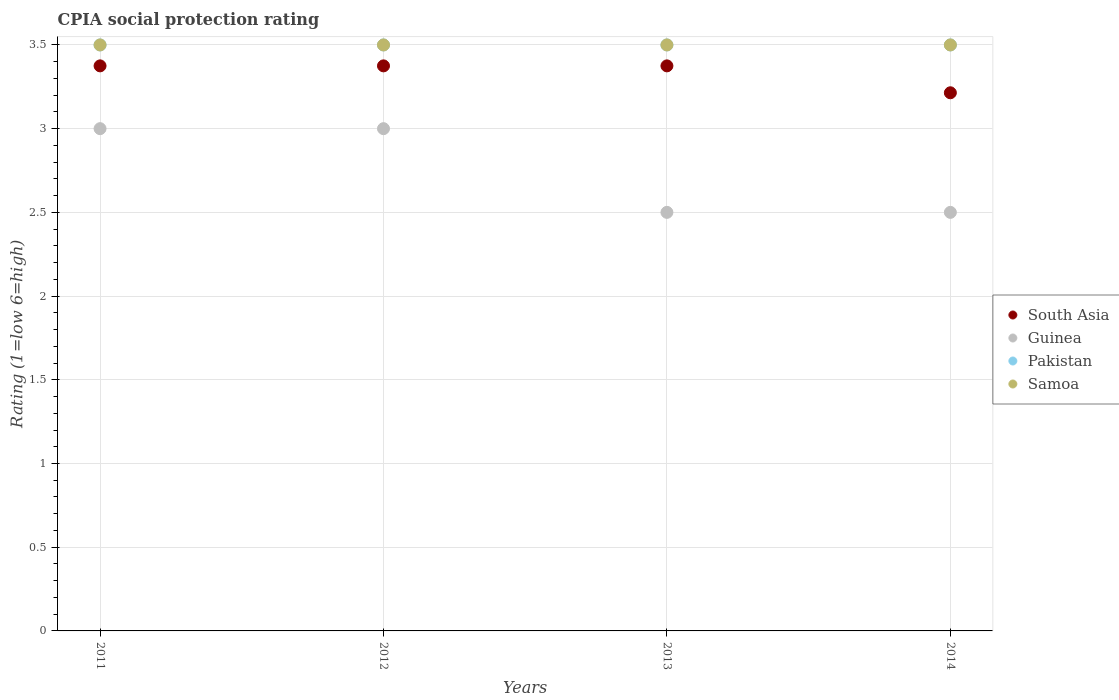Is the number of dotlines equal to the number of legend labels?
Keep it short and to the point. Yes. What is the CPIA rating in South Asia in 2011?
Keep it short and to the point. 3.38. Across all years, what is the maximum CPIA rating in South Asia?
Offer a terse response. 3.38. In which year was the CPIA rating in Pakistan maximum?
Your answer should be very brief. 2011. In which year was the CPIA rating in Pakistan minimum?
Provide a short and direct response. 2011. What is the difference between the CPIA rating in Pakistan in 2013 and that in 2014?
Give a very brief answer. 0. What is the difference between the CPIA rating in Samoa in 2014 and the CPIA rating in South Asia in 2012?
Offer a very short reply. 0.12. What is the average CPIA rating in South Asia per year?
Ensure brevity in your answer.  3.33. In how many years, is the CPIA rating in Guinea greater than 1?
Offer a terse response. 4. What is the ratio of the CPIA rating in Guinea in 2011 to that in 2012?
Ensure brevity in your answer.  1. Is it the case that in every year, the sum of the CPIA rating in Samoa and CPIA rating in Pakistan  is greater than the CPIA rating in Guinea?
Offer a very short reply. Yes. Does the CPIA rating in Pakistan monotonically increase over the years?
Make the answer very short. No. How many dotlines are there?
Provide a short and direct response. 4. How many years are there in the graph?
Offer a terse response. 4. Are the values on the major ticks of Y-axis written in scientific E-notation?
Provide a succinct answer. No. Does the graph contain any zero values?
Make the answer very short. No. Where does the legend appear in the graph?
Your response must be concise. Center right. What is the title of the graph?
Offer a terse response. CPIA social protection rating. What is the label or title of the X-axis?
Keep it short and to the point. Years. What is the label or title of the Y-axis?
Your answer should be very brief. Rating (1=low 6=high). What is the Rating (1=low 6=high) of South Asia in 2011?
Offer a very short reply. 3.38. What is the Rating (1=low 6=high) of Samoa in 2011?
Your answer should be very brief. 3.5. What is the Rating (1=low 6=high) in South Asia in 2012?
Your response must be concise. 3.38. What is the Rating (1=low 6=high) of Guinea in 2012?
Give a very brief answer. 3. What is the Rating (1=low 6=high) of Pakistan in 2012?
Your answer should be compact. 3.5. What is the Rating (1=low 6=high) in Samoa in 2012?
Offer a terse response. 3.5. What is the Rating (1=low 6=high) of South Asia in 2013?
Offer a very short reply. 3.38. What is the Rating (1=low 6=high) in Guinea in 2013?
Ensure brevity in your answer.  2.5. What is the Rating (1=low 6=high) in Pakistan in 2013?
Offer a terse response. 3.5. What is the Rating (1=low 6=high) of Samoa in 2013?
Offer a terse response. 3.5. What is the Rating (1=low 6=high) of South Asia in 2014?
Your answer should be very brief. 3.21. What is the Rating (1=low 6=high) in Pakistan in 2014?
Provide a succinct answer. 3.5. What is the Rating (1=low 6=high) in Samoa in 2014?
Offer a terse response. 3.5. Across all years, what is the maximum Rating (1=low 6=high) in South Asia?
Your answer should be very brief. 3.38. Across all years, what is the maximum Rating (1=low 6=high) in Pakistan?
Your response must be concise. 3.5. Across all years, what is the maximum Rating (1=low 6=high) of Samoa?
Your response must be concise. 3.5. Across all years, what is the minimum Rating (1=low 6=high) in South Asia?
Offer a terse response. 3.21. Across all years, what is the minimum Rating (1=low 6=high) of Pakistan?
Your answer should be compact. 3.5. Across all years, what is the minimum Rating (1=low 6=high) in Samoa?
Make the answer very short. 3.5. What is the total Rating (1=low 6=high) in South Asia in the graph?
Offer a very short reply. 13.34. What is the total Rating (1=low 6=high) of Guinea in the graph?
Provide a succinct answer. 11. What is the difference between the Rating (1=low 6=high) of Samoa in 2011 and that in 2012?
Provide a succinct answer. 0. What is the difference between the Rating (1=low 6=high) of Guinea in 2011 and that in 2013?
Keep it short and to the point. 0.5. What is the difference between the Rating (1=low 6=high) of Samoa in 2011 and that in 2013?
Provide a short and direct response. 0. What is the difference between the Rating (1=low 6=high) in South Asia in 2011 and that in 2014?
Offer a very short reply. 0.16. What is the difference between the Rating (1=low 6=high) of Guinea in 2011 and that in 2014?
Keep it short and to the point. 0.5. What is the difference between the Rating (1=low 6=high) in Pakistan in 2011 and that in 2014?
Provide a short and direct response. 0. What is the difference between the Rating (1=low 6=high) of South Asia in 2012 and that in 2013?
Provide a short and direct response. 0. What is the difference between the Rating (1=low 6=high) in Guinea in 2012 and that in 2013?
Offer a terse response. 0.5. What is the difference between the Rating (1=low 6=high) of Pakistan in 2012 and that in 2013?
Ensure brevity in your answer.  0. What is the difference between the Rating (1=low 6=high) of South Asia in 2012 and that in 2014?
Offer a very short reply. 0.16. What is the difference between the Rating (1=low 6=high) in Guinea in 2012 and that in 2014?
Offer a very short reply. 0.5. What is the difference between the Rating (1=low 6=high) in Pakistan in 2012 and that in 2014?
Provide a succinct answer. 0. What is the difference between the Rating (1=low 6=high) of South Asia in 2013 and that in 2014?
Your answer should be very brief. 0.16. What is the difference between the Rating (1=low 6=high) in Guinea in 2013 and that in 2014?
Offer a very short reply. 0. What is the difference between the Rating (1=low 6=high) in South Asia in 2011 and the Rating (1=low 6=high) in Pakistan in 2012?
Your response must be concise. -0.12. What is the difference between the Rating (1=low 6=high) in South Asia in 2011 and the Rating (1=low 6=high) in Samoa in 2012?
Your response must be concise. -0.12. What is the difference between the Rating (1=low 6=high) of South Asia in 2011 and the Rating (1=low 6=high) of Guinea in 2013?
Your response must be concise. 0.88. What is the difference between the Rating (1=low 6=high) of South Asia in 2011 and the Rating (1=low 6=high) of Pakistan in 2013?
Ensure brevity in your answer.  -0.12. What is the difference between the Rating (1=low 6=high) of South Asia in 2011 and the Rating (1=low 6=high) of Samoa in 2013?
Give a very brief answer. -0.12. What is the difference between the Rating (1=low 6=high) in Guinea in 2011 and the Rating (1=low 6=high) in Pakistan in 2013?
Your answer should be very brief. -0.5. What is the difference between the Rating (1=low 6=high) of Pakistan in 2011 and the Rating (1=low 6=high) of Samoa in 2013?
Your answer should be very brief. 0. What is the difference between the Rating (1=low 6=high) of South Asia in 2011 and the Rating (1=low 6=high) of Guinea in 2014?
Keep it short and to the point. 0.88. What is the difference between the Rating (1=low 6=high) of South Asia in 2011 and the Rating (1=low 6=high) of Pakistan in 2014?
Your response must be concise. -0.12. What is the difference between the Rating (1=low 6=high) in South Asia in 2011 and the Rating (1=low 6=high) in Samoa in 2014?
Provide a short and direct response. -0.12. What is the difference between the Rating (1=low 6=high) in Guinea in 2011 and the Rating (1=low 6=high) in Pakistan in 2014?
Offer a very short reply. -0.5. What is the difference between the Rating (1=low 6=high) in Pakistan in 2011 and the Rating (1=low 6=high) in Samoa in 2014?
Keep it short and to the point. 0. What is the difference between the Rating (1=low 6=high) in South Asia in 2012 and the Rating (1=low 6=high) in Pakistan in 2013?
Ensure brevity in your answer.  -0.12. What is the difference between the Rating (1=low 6=high) in South Asia in 2012 and the Rating (1=low 6=high) in Samoa in 2013?
Keep it short and to the point. -0.12. What is the difference between the Rating (1=low 6=high) in Pakistan in 2012 and the Rating (1=low 6=high) in Samoa in 2013?
Keep it short and to the point. 0. What is the difference between the Rating (1=low 6=high) in South Asia in 2012 and the Rating (1=low 6=high) in Guinea in 2014?
Provide a short and direct response. 0.88. What is the difference between the Rating (1=low 6=high) of South Asia in 2012 and the Rating (1=low 6=high) of Pakistan in 2014?
Offer a terse response. -0.12. What is the difference between the Rating (1=low 6=high) of South Asia in 2012 and the Rating (1=low 6=high) of Samoa in 2014?
Your response must be concise. -0.12. What is the difference between the Rating (1=low 6=high) of South Asia in 2013 and the Rating (1=low 6=high) of Pakistan in 2014?
Provide a short and direct response. -0.12. What is the difference between the Rating (1=low 6=high) in South Asia in 2013 and the Rating (1=low 6=high) in Samoa in 2014?
Provide a short and direct response. -0.12. What is the difference between the Rating (1=low 6=high) in Guinea in 2013 and the Rating (1=low 6=high) in Pakistan in 2014?
Your answer should be very brief. -1. What is the difference between the Rating (1=low 6=high) in Guinea in 2013 and the Rating (1=low 6=high) in Samoa in 2014?
Your answer should be very brief. -1. What is the average Rating (1=low 6=high) of South Asia per year?
Ensure brevity in your answer.  3.33. What is the average Rating (1=low 6=high) of Guinea per year?
Offer a terse response. 2.75. What is the average Rating (1=low 6=high) of Samoa per year?
Your answer should be very brief. 3.5. In the year 2011, what is the difference between the Rating (1=low 6=high) in South Asia and Rating (1=low 6=high) in Pakistan?
Keep it short and to the point. -0.12. In the year 2011, what is the difference between the Rating (1=low 6=high) of South Asia and Rating (1=low 6=high) of Samoa?
Offer a very short reply. -0.12. In the year 2011, what is the difference between the Rating (1=low 6=high) of Guinea and Rating (1=low 6=high) of Samoa?
Offer a terse response. -0.5. In the year 2011, what is the difference between the Rating (1=low 6=high) in Pakistan and Rating (1=low 6=high) in Samoa?
Provide a short and direct response. 0. In the year 2012, what is the difference between the Rating (1=low 6=high) in South Asia and Rating (1=low 6=high) in Guinea?
Ensure brevity in your answer.  0.38. In the year 2012, what is the difference between the Rating (1=low 6=high) of South Asia and Rating (1=low 6=high) of Pakistan?
Provide a succinct answer. -0.12. In the year 2012, what is the difference between the Rating (1=low 6=high) of South Asia and Rating (1=low 6=high) of Samoa?
Give a very brief answer. -0.12. In the year 2013, what is the difference between the Rating (1=low 6=high) in South Asia and Rating (1=low 6=high) in Guinea?
Your answer should be compact. 0.88. In the year 2013, what is the difference between the Rating (1=low 6=high) in South Asia and Rating (1=low 6=high) in Pakistan?
Give a very brief answer. -0.12. In the year 2013, what is the difference between the Rating (1=low 6=high) of South Asia and Rating (1=low 6=high) of Samoa?
Provide a succinct answer. -0.12. In the year 2013, what is the difference between the Rating (1=low 6=high) of Guinea and Rating (1=low 6=high) of Samoa?
Your answer should be very brief. -1. In the year 2013, what is the difference between the Rating (1=low 6=high) of Pakistan and Rating (1=low 6=high) of Samoa?
Keep it short and to the point. 0. In the year 2014, what is the difference between the Rating (1=low 6=high) in South Asia and Rating (1=low 6=high) in Pakistan?
Give a very brief answer. -0.29. In the year 2014, what is the difference between the Rating (1=low 6=high) of South Asia and Rating (1=low 6=high) of Samoa?
Your answer should be compact. -0.29. In the year 2014, what is the difference between the Rating (1=low 6=high) in Guinea and Rating (1=low 6=high) in Samoa?
Provide a short and direct response. -1. In the year 2014, what is the difference between the Rating (1=low 6=high) of Pakistan and Rating (1=low 6=high) of Samoa?
Make the answer very short. 0. What is the ratio of the Rating (1=low 6=high) in South Asia in 2011 to that in 2012?
Your response must be concise. 1. What is the ratio of the Rating (1=low 6=high) in Guinea in 2011 to that in 2012?
Make the answer very short. 1. What is the ratio of the Rating (1=low 6=high) of Pakistan in 2011 to that in 2012?
Offer a terse response. 1. What is the ratio of the Rating (1=low 6=high) in Pakistan in 2011 to that in 2013?
Offer a terse response. 1. What is the ratio of the Rating (1=low 6=high) of South Asia in 2011 to that in 2014?
Give a very brief answer. 1.05. What is the ratio of the Rating (1=low 6=high) of Guinea in 2011 to that in 2014?
Provide a succinct answer. 1.2. What is the ratio of the Rating (1=low 6=high) of Samoa in 2011 to that in 2014?
Your response must be concise. 1. What is the ratio of the Rating (1=low 6=high) in Samoa in 2012 to that in 2013?
Your answer should be compact. 1. What is the ratio of the Rating (1=low 6=high) in Guinea in 2012 to that in 2014?
Your answer should be compact. 1.2. What is the ratio of the Rating (1=low 6=high) of Samoa in 2012 to that in 2014?
Offer a terse response. 1. What is the ratio of the Rating (1=low 6=high) in South Asia in 2013 to that in 2014?
Offer a terse response. 1.05. What is the ratio of the Rating (1=low 6=high) of Guinea in 2013 to that in 2014?
Your answer should be very brief. 1. What is the ratio of the Rating (1=low 6=high) in Pakistan in 2013 to that in 2014?
Keep it short and to the point. 1. What is the ratio of the Rating (1=low 6=high) in Samoa in 2013 to that in 2014?
Offer a very short reply. 1. What is the difference between the highest and the second highest Rating (1=low 6=high) in South Asia?
Provide a short and direct response. 0. What is the difference between the highest and the second highest Rating (1=low 6=high) of Samoa?
Make the answer very short. 0. What is the difference between the highest and the lowest Rating (1=low 6=high) of South Asia?
Keep it short and to the point. 0.16. 